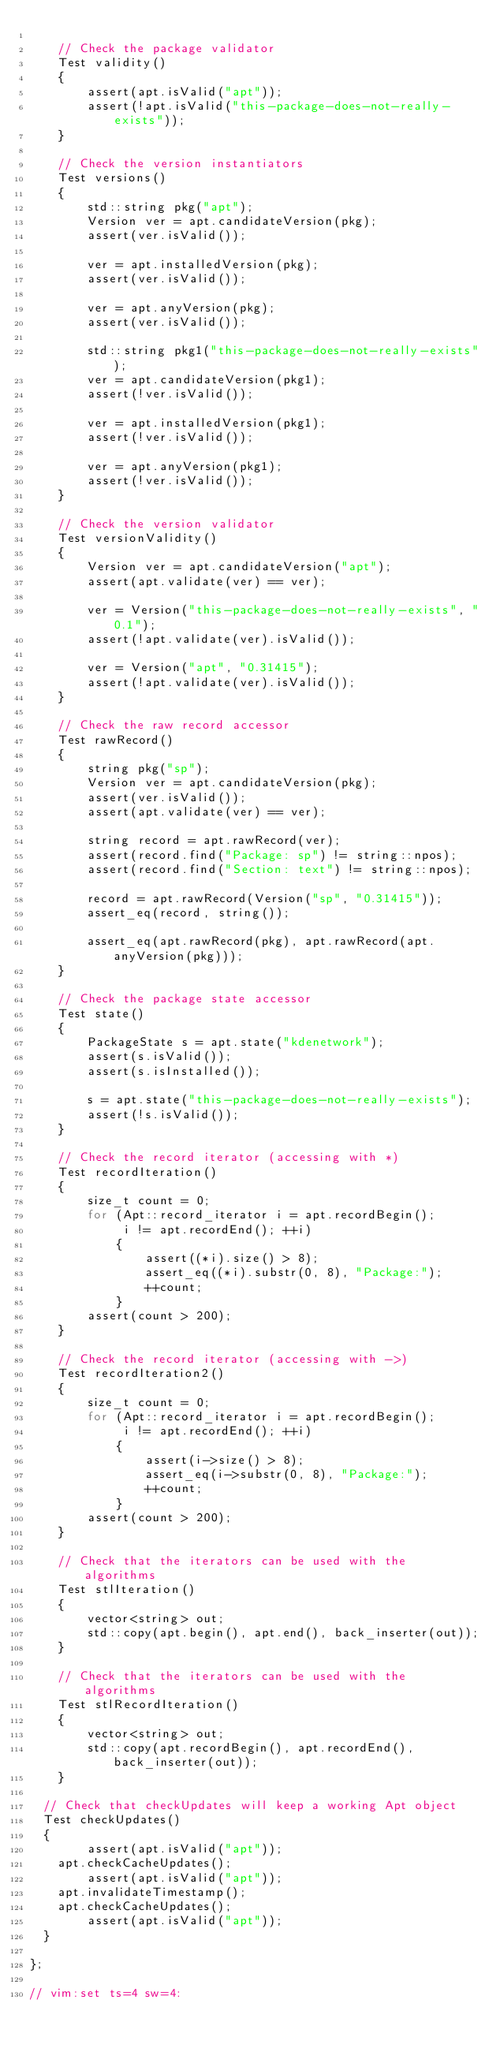Convert code to text. <code><loc_0><loc_0><loc_500><loc_500><_C_>
    // Check the package validator
    Test validity()
    {
        assert(apt.isValid("apt"));
        assert(!apt.isValid("this-package-does-not-really-exists"));
    }

    // Check the version instantiators
    Test versions()
    {
        std::string pkg("apt");
        Version ver = apt.candidateVersion(pkg);
        assert(ver.isValid());
        
        ver = apt.installedVersion(pkg);
        assert(ver.isValid());

        ver = apt.anyVersion(pkg);
        assert(ver.isValid());

        std::string pkg1("this-package-does-not-really-exists");
        ver = apt.candidateVersion(pkg1);
        assert(!ver.isValid());
        
        ver = apt.installedVersion(pkg1);
        assert(!ver.isValid());

        ver = apt.anyVersion(pkg1);
        assert(!ver.isValid());
    }

    // Check the version validator
    Test versionValidity()
    {
        Version ver = apt.candidateVersion("apt");
        assert(apt.validate(ver) == ver);

        ver = Version("this-package-does-not-really-exists", "0.1");
        assert(!apt.validate(ver).isValid());

        ver = Version("apt", "0.31415");
        assert(!apt.validate(ver).isValid());
    }

    // Check the raw record accessor
    Test rawRecord()
    {
        string pkg("sp");
        Version ver = apt.candidateVersion(pkg);
        assert(ver.isValid());
        assert(apt.validate(ver) == ver);

        string record = apt.rawRecord(ver);
        assert(record.find("Package: sp") != string::npos);
        assert(record.find("Section: text") != string::npos);

        record = apt.rawRecord(Version("sp", "0.31415"));
        assert_eq(record, string());

        assert_eq(apt.rawRecord(pkg), apt.rawRecord(apt.anyVersion(pkg)));
    }

    // Check the package state accessor
    Test state()
    {
        PackageState s = apt.state("kdenetwork");
        assert(s.isValid());
        assert(s.isInstalled());

        s = apt.state("this-package-does-not-really-exists");
        assert(!s.isValid());
    }

    // Check the record iterator (accessing with *)
    Test recordIteration()
    {
        size_t count = 0;
        for (Apt::record_iterator i = apt.recordBegin();
             i != apt.recordEnd(); ++i)
            {
                assert((*i).size() > 8);
                assert_eq((*i).substr(0, 8), "Package:");
                ++count;
            }
        assert(count > 200);
    }

    // Check the record iterator (accessing with ->)
    Test recordIteration2()
    {
        size_t count = 0;
        for (Apt::record_iterator i = apt.recordBegin();
             i != apt.recordEnd(); ++i)
            {
                assert(i->size() > 8);
                assert_eq(i->substr(0, 8), "Package:");
                ++count;
            }
        assert(count > 200);
    }

    // Check that the iterators can be used with the algorithms
    Test stlIteration()
    {
        vector<string> out;
        std::copy(apt.begin(), apt.end(), back_inserter(out));
    }

    // Check that the iterators can be used with the algorithms
    Test stlRecordIteration()
    {
        vector<string> out;
        std::copy(apt.recordBegin(), apt.recordEnd(), back_inserter(out));
    }

	// Check that checkUpdates will keep a working Apt object
	Test checkUpdates()
	{
        assert(apt.isValid("apt"));
		apt.checkCacheUpdates();
        assert(apt.isValid("apt"));
		apt.invalidateTimestamp();		
		apt.checkCacheUpdates();
        assert(apt.isValid("apt"));
	}

};

// vim:set ts=4 sw=4:
</code> 